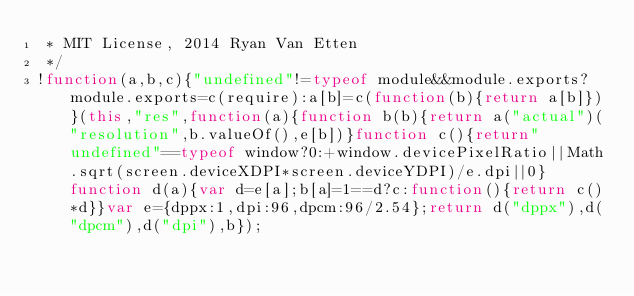Convert code to text. <code><loc_0><loc_0><loc_500><loc_500><_JavaScript_> * MIT License, 2014 Ryan Van Etten
 */
!function(a,b,c){"undefined"!=typeof module&&module.exports?module.exports=c(require):a[b]=c(function(b){return a[b]})}(this,"res",function(a){function b(b){return a("actual")("resolution",b.valueOf(),e[b])}function c(){return"undefined"==typeof window?0:+window.devicePixelRatio||Math.sqrt(screen.deviceXDPI*screen.deviceYDPI)/e.dpi||0}function d(a){var d=e[a];b[a]=1==d?c:function(){return c()*d}}var e={dppx:1,dpi:96,dpcm:96/2.54};return d("dppx"),d("dpcm"),d("dpi"),b});</code> 